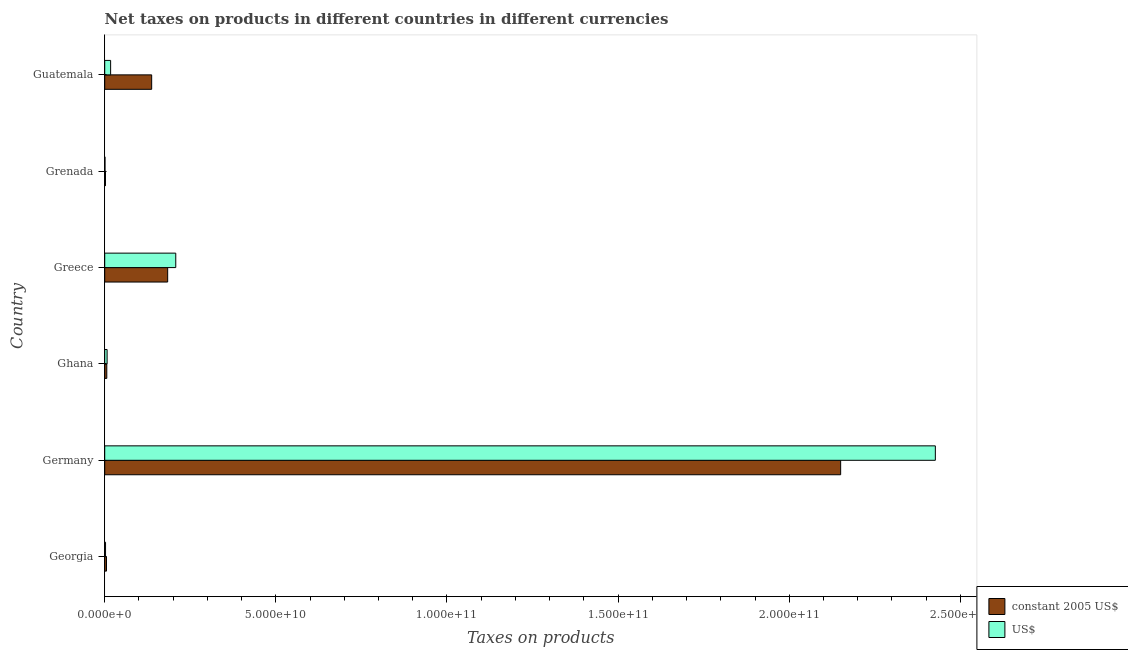How many different coloured bars are there?
Your answer should be compact. 2. How many groups of bars are there?
Provide a succinct answer. 6. Are the number of bars per tick equal to the number of legend labels?
Keep it short and to the point. Yes. Are the number of bars on each tick of the Y-axis equal?
Your answer should be compact. Yes. How many bars are there on the 3rd tick from the top?
Keep it short and to the point. 2. How many bars are there on the 3rd tick from the bottom?
Your response must be concise. 2. What is the label of the 2nd group of bars from the top?
Provide a short and direct response. Grenada. What is the net taxes in us$ in Ghana?
Your response must be concise. 7.00e+08. Across all countries, what is the maximum net taxes in constant 2005 us$?
Your answer should be compact. 2.15e+11. Across all countries, what is the minimum net taxes in us$?
Offer a very short reply. 8.12e+07. In which country was the net taxes in us$ minimum?
Ensure brevity in your answer.  Grenada. What is the total net taxes in constant 2005 us$ in the graph?
Your response must be concise. 2.48e+11. What is the difference between the net taxes in us$ in Georgia and that in Ghana?
Offer a very short reply. -4.57e+08. What is the difference between the net taxes in constant 2005 us$ in Grenada and the net taxes in us$ in Ghana?
Your answer should be very brief. -4.81e+08. What is the average net taxes in constant 2005 us$ per country?
Offer a very short reply. 4.14e+1. What is the difference between the net taxes in constant 2005 us$ and net taxes in us$ in Germany?
Provide a succinct answer. -2.77e+1. In how many countries, is the net taxes in us$ greater than 220000000000 units?
Provide a succinct answer. 1. What is the ratio of the net taxes in constant 2005 us$ in Georgia to that in Germany?
Provide a succinct answer. 0. Is the net taxes in us$ in Ghana less than that in Greece?
Make the answer very short. Yes. What is the difference between the highest and the second highest net taxes in constant 2005 us$?
Offer a terse response. 1.97e+11. What is the difference between the highest and the lowest net taxes in us$?
Offer a very short reply. 2.43e+11. Is the sum of the net taxes in constant 2005 us$ in Ghana and Greece greater than the maximum net taxes in us$ across all countries?
Make the answer very short. No. What does the 2nd bar from the top in Greece represents?
Your response must be concise. Constant 2005 us$. What does the 2nd bar from the bottom in Georgia represents?
Your answer should be very brief. US$. How many bars are there?
Your answer should be very brief. 12. How many countries are there in the graph?
Offer a terse response. 6. What is the difference between two consecutive major ticks on the X-axis?
Make the answer very short. 5.00e+1. How many legend labels are there?
Provide a short and direct response. 2. What is the title of the graph?
Your response must be concise. Net taxes on products in different countries in different currencies. Does "Long-term debt" appear as one of the legend labels in the graph?
Your response must be concise. No. What is the label or title of the X-axis?
Make the answer very short. Taxes on products. What is the label or title of the Y-axis?
Provide a short and direct response. Country. What is the Taxes on products of constant 2005 US$ in Georgia?
Keep it short and to the point. 5.22e+08. What is the Taxes on products of US$ in Georgia?
Your answer should be compact. 2.43e+08. What is the Taxes on products in constant 2005 US$ in Germany?
Your answer should be compact. 2.15e+11. What is the Taxes on products in US$ in Germany?
Ensure brevity in your answer.  2.43e+11. What is the Taxes on products of constant 2005 US$ in Ghana?
Make the answer very short. 6.07e+08. What is the Taxes on products of US$ in Ghana?
Make the answer very short. 7.00e+08. What is the Taxes on products of constant 2005 US$ in Greece?
Offer a very short reply. 1.84e+1. What is the Taxes on products of US$ in Greece?
Make the answer very short. 2.08e+1. What is the Taxes on products in constant 2005 US$ in Grenada?
Your answer should be compact. 2.19e+08. What is the Taxes on products in US$ in Grenada?
Provide a short and direct response. 8.12e+07. What is the Taxes on products of constant 2005 US$ in Guatemala?
Make the answer very short. 1.37e+1. What is the Taxes on products in US$ in Guatemala?
Your answer should be very brief. 1.73e+09. Across all countries, what is the maximum Taxes on products of constant 2005 US$?
Your answer should be compact. 2.15e+11. Across all countries, what is the maximum Taxes on products in US$?
Provide a succinct answer. 2.43e+11. Across all countries, what is the minimum Taxes on products in constant 2005 US$?
Ensure brevity in your answer.  2.19e+08. Across all countries, what is the minimum Taxes on products in US$?
Make the answer very short. 8.12e+07. What is the total Taxes on products of constant 2005 US$ in the graph?
Give a very brief answer. 2.48e+11. What is the total Taxes on products of US$ in the graph?
Offer a terse response. 2.66e+11. What is the difference between the Taxes on products of constant 2005 US$ in Georgia and that in Germany?
Give a very brief answer. -2.14e+11. What is the difference between the Taxes on products in US$ in Georgia and that in Germany?
Give a very brief answer. -2.42e+11. What is the difference between the Taxes on products in constant 2005 US$ in Georgia and that in Ghana?
Keep it short and to the point. -8.50e+07. What is the difference between the Taxes on products of US$ in Georgia and that in Ghana?
Your response must be concise. -4.57e+08. What is the difference between the Taxes on products in constant 2005 US$ in Georgia and that in Greece?
Provide a short and direct response. -1.79e+1. What is the difference between the Taxes on products of US$ in Georgia and that in Greece?
Give a very brief answer. -2.05e+1. What is the difference between the Taxes on products in constant 2005 US$ in Georgia and that in Grenada?
Ensure brevity in your answer.  3.03e+08. What is the difference between the Taxes on products in US$ in Georgia and that in Grenada?
Provide a short and direct response. 1.62e+08. What is the difference between the Taxes on products of constant 2005 US$ in Georgia and that in Guatemala?
Provide a short and direct response. -1.32e+1. What is the difference between the Taxes on products of US$ in Georgia and that in Guatemala?
Ensure brevity in your answer.  -1.48e+09. What is the difference between the Taxes on products in constant 2005 US$ in Germany and that in Ghana?
Provide a short and direct response. 2.14e+11. What is the difference between the Taxes on products of US$ in Germany and that in Ghana?
Ensure brevity in your answer.  2.42e+11. What is the difference between the Taxes on products of constant 2005 US$ in Germany and that in Greece?
Make the answer very short. 1.97e+11. What is the difference between the Taxes on products in US$ in Germany and that in Greece?
Make the answer very short. 2.22e+11. What is the difference between the Taxes on products in constant 2005 US$ in Germany and that in Grenada?
Ensure brevity in your answer.  2.15e+11. What is the difference between the Taxes on products of US$ in Germany and that in Grenada?
Your answer should be compact. 2.43e+11. What is the difference between the Taxes on products in constant 2005 US$ in Germany and that in Guatemala?
Ensure brevity in your answer.  2.01e+11. What is the difference between the Taxes on products in US$ in Germany and that in Guatemala?
Keep it short and to the point. 2.41e+11. What is the difference between the Taxes on products in constant 2005 US$ in Ghana and that in Greece?
Give a very brief answer. -1.78e+1. What is the difference between the Taxes on products of US$ in Ghana and that in Greece?
Give a very brief answer. -2.01e+1. What is the difference between the Taxes on products in constant 2005 US$ in Ghana and that in Grenada?
Make the answer very short. 3.88e+08. What is the difference between the Taxes on products in US$ in Ghana and that in Grenada?
Ensure brevity in your answer.  6.19e+08. What is the difference between the Taxes on products in constant 2005 US$ in Ghana and that in Guatemala?
Your response must be concise. -1.31e+1. What is the difference between the Taxes on products in US$ in Ghana and that in Guatemala?
Make the answer very short. -1.03e+09. What is the difference between the Taxes on products of constant 2005 US$ in Greece and that in Grenada?
Make the answer very short. 1.82e+1. What is the difference between the Taxes on products in US$ in Greece and that in Grenada?
Ensure brevity in your answer.  2.07e+1. What is the difference between the Taxes on products of constant 2005 US$ in Greece and that in Guatemala?
Your answer should be compact. 4.68e+09. What is the difference between the Taxes on products in US$ in Greece and that in Guatemala?
Your answer should be very brief. 1.90e+1. What is the difference between the Taxes on products in constant 2005 US$ in Grenada and that in Guatemala?
Ensure brevity in your answer.  -1.35e+1. What is the difference between the Taxes on products of US$ in Grenada and that in Guatemala?
Your response must be concise. -1.65e+09. What is the difference between the Taxes on products in constant 2005 US$ in Georgia and the Taxes on products in US$ in Germany?
Give a very brief answer. -2.42e+11. What is the difference between the Taxes on products of constant 2005 US$ in Georgia and the Taxes on products of US$ in Ghana?
Your answer should be very brief. -1.78e+08. What is the difference between the Taxes on products in constant 2005 US$ in Georgia and the Taxes on products in US$ in Greece?
Give a very brief answer. -2.02e+1. What is the difference between the Taxes on products in constant 2005 US$ in Georgia and the Taxes on products in US$ in Grenada?
Provide a short and direct response. 4.41e+08. What is the difference between the Taxes on products in constant 2005 US$ in Georgia and the Taxes on products in US$ in Guatemala?
Provide a short and direct response. -1.21e+09. What is the difference between the Taxes on products of constant 2005 US$ in Germany and the Taxes on products of US$ in Ghana?
Give a very brief answer. 2.14e+11. What is the difference between the Taxes on products in constant 2005 US$ in Germany and the Taxes on products in US$ in Greece?
Offer a very short reply. 1.94e+11. What is the difference between the Taxes on products of constant 2005 US$ in Germany and the Taxes on products of US$ in Grenada?
Offer a terse response. 2.15e+11. What is the difference between the Taxes on products in constant 2005 US$ in Germany and the Taxes on products in US$ in Guatemala?
Provide a short and direct response. 2.13e+11. What is the difference between the Taxes on products of constant 2005 US$ in Ghana and the Taxes on products of US$ in Greece?
Your answer should be compact. -2.02e+1. What is the difference between the Taxes on products in constant 2005 US$ in Ghana and the Taxes on products in US$ in Grenada?
Provide a succinct answer. 5.26e+08. What is the difference between the Taxes on products of constant 2005 US$ in Ghana and the Taxes on products of US$ in Guatemala?
Make the answer very short. -1.12e+09. What is the difference between the Taxes on products in constant 2005 US$ in Greece and the Taxes on products in US$ in Grenada?
Keep it short and to the point. 1.83e+1. What is the difference between the Taxes on products of constant 2005 US$ in Greece and the Taxes on products of US$ in Guatemala?
Keep it short and to the point. 1.67e+1. What is the difference between the Taxes on products in constant 2005 US$ in Grenada and the Taxes on products in US$ in Guatemala?
Provide a short and direct response. -1.51e+09. What is the average Taxes on products in constant 2005 US$ per country?
Offer a very short reply. 4.14e+1. What is the average Taxes on products in US$ per country?
Give a very brief answer. 4.44e+1. What is the difference between the Taxes on products in constant 2005 US$ and Taxes on products in US$ in Georgia?
Offer a terse response. 2.79e+08. What is the difference between the Taxes on products in constant 2005 US$ and Taxes on products in US$ in Germany?
Your answer should be compact. -2.77e+1. What is the difference between the Taxes on products in constant 2005 US$ and Taxes on products in US$ in Ghana?
Offer a very short reply. -9.33e+07. What is the difference between the Taxes on products of constant 2005 US$ and Taxes on products of US$ in Greece?
Make the answer very short. -2.37e+09. What is the difference between the Taxes on products in constant 2005 US$ and Taxes on products in US$ in Grenada?
Provide a succinct answer. 1.38e+08. What is the difference between the Taxes on products in constant 2005 US$ and Taxes on products in US$ in Guatemala?
Offer a terse response. 1.20e+1. What is the ratio of the Taxes on products in constant 2005 US$ in Georgia to that in Germany?
Ensure brevity in your answer.  0. What is the ratio of the Taxes on products in constant 2005 US$ in Georgia to that in Ghana?
Make the answer very short. 0.86. What is the ratio of the Taxes on products of US$ in Georgia to that in Ghana?
Your answer should be compact. 0.35. What is the ratio of the Taxes on products in constant 2005 US$ in Georgia to that in Greece?
Your answer should be compact. 0.03. What is the ratio of the Taxes on products of US$ in Georgia to that in Greece?
Offer a terse response. 0.01. What is the ratio of the Taxes on products of constant 2005 US$ in Georgia to that in Grenada?
Keep it short and to the point. 2.38. What is the ratio of the Taxes on products in US$ in Georgia to that in Grenada?
Offer a terse response. 3. What is the ratio of the Taxes on products of constant 2005 US$ in Georgia to that in Guatemala?
Offer a terse response. 0.04. What is the ratio of the Taxes on products of US$ in Georgia to that in Guatemala?
Make the answer very short. 0.14. What is the ratio of the Taxes on products of constant 2005 US$ in Germany to that in Ghana?
Your answer should be compact. 354.12. What is the ratio of the Taxes on products in US$ in Germany to that in Ghana?
Provide a short and direct response. 346.44. What is the ratio of the Taxes on products of constant 2005 US$ in Germany to that in Greece?
Keep it short and to the point. 11.69. What is the ratio of the Taxes on products of US$ in Germany to that in Greece?
Give a very brief answer. 11.69. What is the ratio of the Taxes on products of constant 2005 US$ in Germany to that in Grenada?
Ensure brevity in your answer.  980.38. What is the ratio of the Taxes on products of US$ in Germany to that in Grenada?
Keep it short and to the point. 2987.6. What is the ratio of the Taxes on products in constant 2005 US$ in Germany to that in Guatemala?
Your answer should be compact. 15.68. What is the ratio of the Taxes on products in US$ in Germany to that in Guatemala?
Your answer should be compact. 140.5. What is the ratio of the Taxes on products in constant 2005 US$ in Ghana to that in Greece?
Make the answer very short. 0.03. What is the ratio of the Taxes on products of US$ in Ghana to that in Greece?
Offer a terse response. 0.03. What is the ratio of the Taxes on products in constant 2005 US$ in Ghana to that in Grenada?
Make the answer very short. 2.77. What is the ratio of the Taxes on products of US$ in Ghana to that in Grenada?
Provide a succinct answer. 8.62. What is the ratio of the Taxes on products in constant 2005 US$ in Ghana to that in Guatemala?
Offer a very short reply. 0.04. What is the ratio of the Taxes on products of US$ in Ghana to that in Guatemala?
Offer a very short reply. 0.41. What is the ratio of the Taxes on products in constant 2005 US$ in Greece to that in Grenada?
Your response must be concise. 83.86. What is the ratio of the Taxes on products of US$ in Greece to that in Grenada?
Offer a terse response. 255.55. What is the ratio of the Taxes on products of constant 2005 US$ in Greece to that in Guatemala?
Provide a short and direct response. 1.34. What is the ratio of the Taxes on products in US$ in Greece to that in Guatemala?
Give a very brief answer. 12.02. What is the ratio of the Taxes on products in constant 2005 US$ in Grenada to that in Guatemala?
Your response must be concise. 0.02. What is the ratio of the Taxes on products in US$ in Grenada to that in Guatemala?
Your answer should be very brief. 0.05. What is the difference between the highest and the second highest Taxes on products of constant 2005 US$?
Your response must be concise. 1.97e+11. What is the difference between the highest and the second highest Taxes on products of US$?
Provide a short and direct response. 2.22e+11. What is the difference between the highest and the lowest Taxes on products of constant 2005 US$?
Provide a short and direct response. 2.15e+11. What is the difference between the highest and the lowest Taxes on products of US$?
Your answer should be compact. 2.43e+11. 